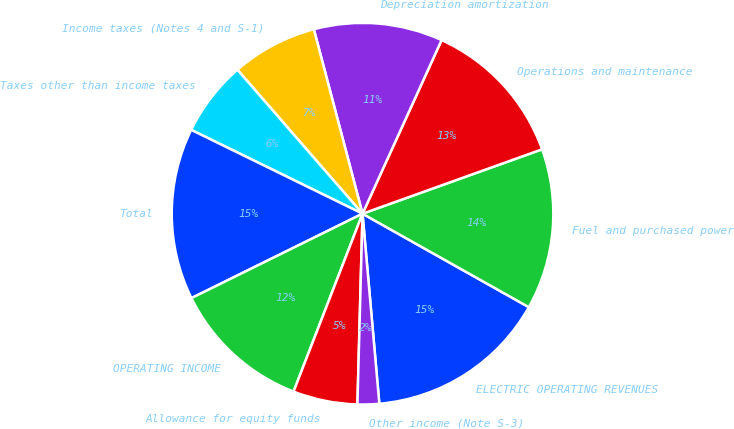Convert chart to OTSL. <chart><loc_0><loc_0><loc_500><loc_500><pie_chart><fcel>ELECTRIC OPERATING REVENUES<fcel>Fuel and purchased power<fcel>Operations and maintenance<fcel>Depreciation amortization<fcel>Income taxes (Notes 4 and S-1)<fcel>Taxes other than income taxes<fcel>Total<fcel>OPERATING INCOME<fcel>Allowance for equity funds<fcel>Other income (Note S-3)<nl><fcel>15.45%<fcel>13.63%<fcel>12.72%<fcel>10.91%<fcel>7.28%<fcel>6.37%<fcel>14.54%<fcel>11.82%<fcel>5.46%<fcel>1.83%<nl></chart> 